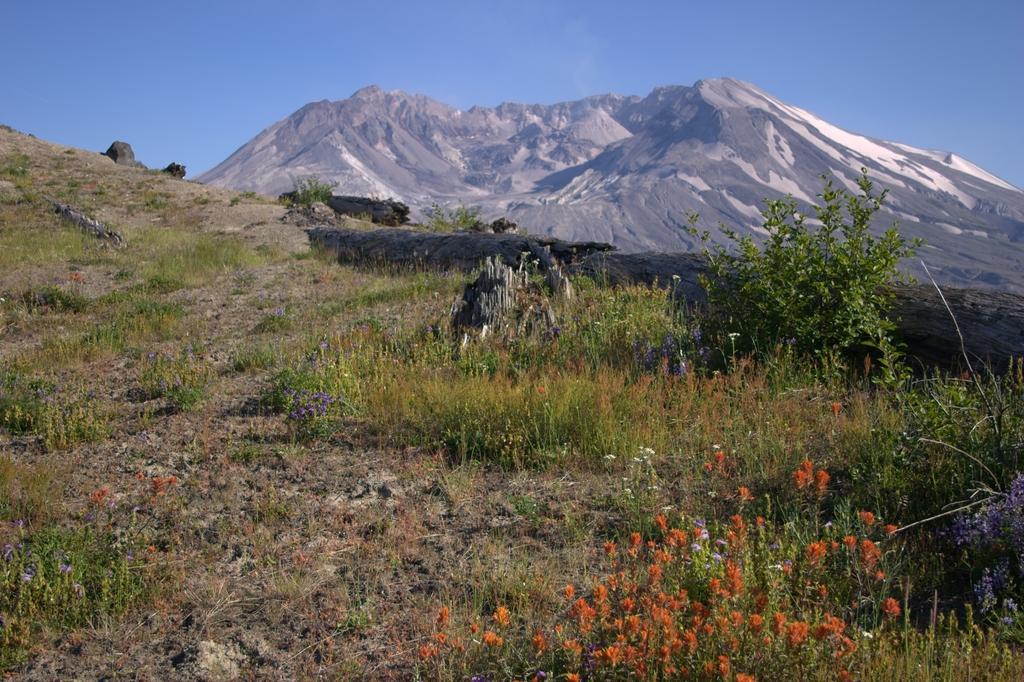In one or two sentences, can you explain what this image depicts? This picture is clicked outside. In the center we can see the plants and the grass. In the background there is a sky and we can see the hills and some other objects. 